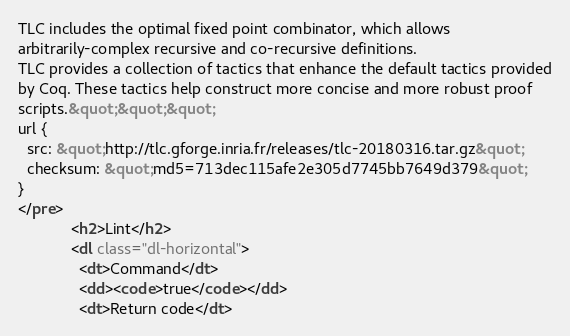<code> <loc_0><loc_0><loc_500><loc_500><_HTML_>TLC includes the optimal fixed point combinator, which allows
arbitrarily-complex recursive and co-recursive definitions.
TLC provides a collection of tactics that enhance the default tactics provided
by Coq. These tactics help construct more concise and more robust proof
scripts.&quot;&quot;&quot;
url {
  src: &quot;http://tlc.gforge.inria.fr/releases/tlc-20180316.tar.gz&quot;
  checksum: &quot;md5=713dec115afe2e305d7745bb7649d379&quot;
}
</pre>
            <h2>Lint</h2>
            <dl class="dl-horizontal">
              <dt>Command</dt>
              <dd><code>true</code></dd>
              <dt>Return code</dt></code> 